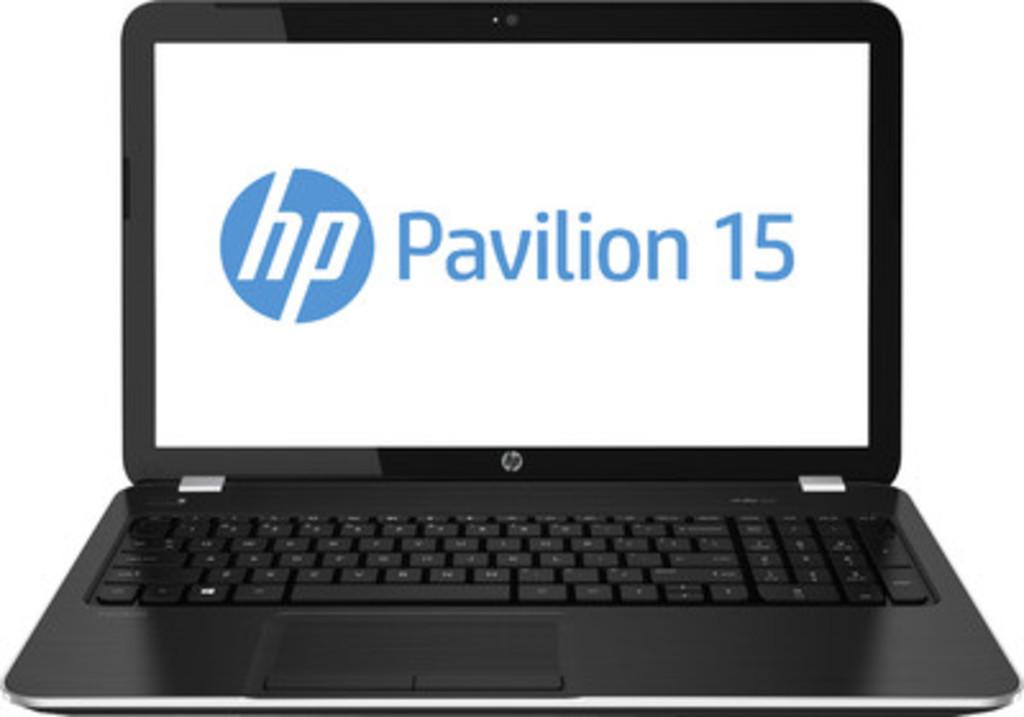What model of laptop is this?
Offer a very short reply. Hp. 